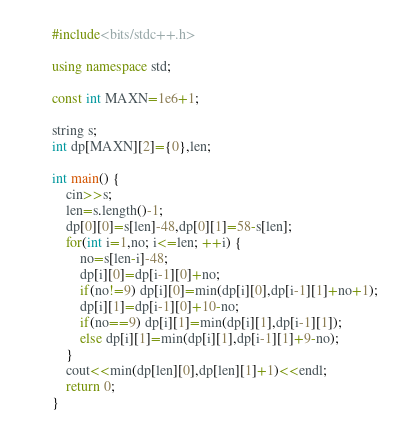<code> <loc_0><loc_0><loc_500><loc_500><_C++_>#include<bits/stdc++.h>

using namespace std;

const int MAXN=1e6+1;

string s;
int dp[MAXN][2]={0},len;

int main() {
	cin>>s;
	len=s.length()-1;
	dp[0][0]=s[len]-48,dp[0][1]=58-s[len];
	for(int i=1,no; i<=len; ++i) {
		no=s[len-i]-48;
		dp[i][0]=dp[i-1][0]+no;
		if(no!=9) dp[i][0]=min(dp[i][0],dp[i-1][1]+no+1);
		dp[i][1]=dp[i-1][0]+10-no;
		if(no==9) dp[i][1]=min(dp[i][1],dp[i-1][1]);
		else dp[i][1]=min(dp[i][1],dp[i-1][1]+9-no);
	}
	cout<<min(dp[len][0],dp[len][1]+1)<<endl;
	return 0;
}</code> 